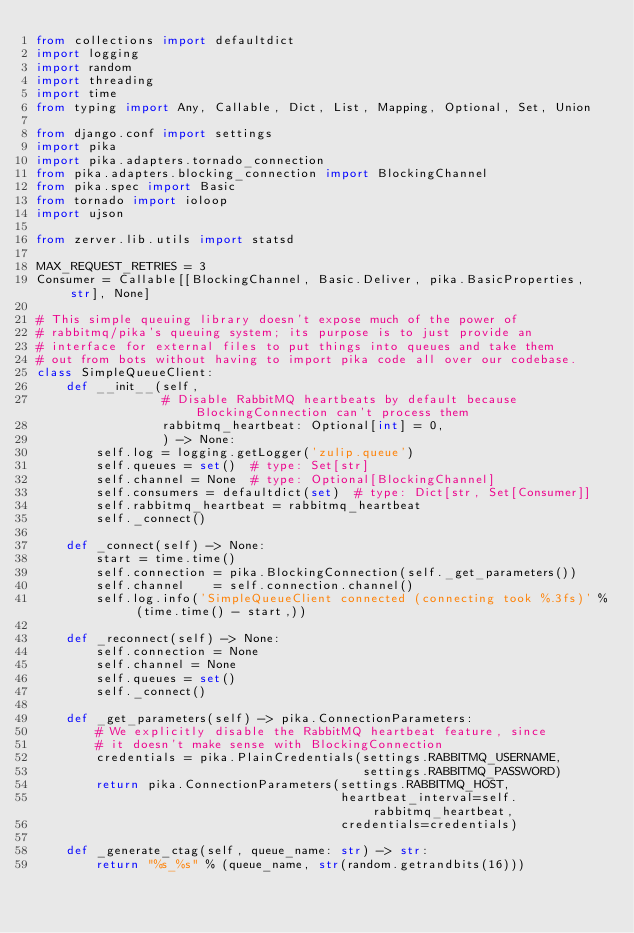Convert code to text. <code><loc_0><loc_0><loc_500><loc_500><_Python_>from collections import defaultdict
import logging
import random
import threading
import time
from typing import Any, Callable, Dict, List, Mapping, Optional, Set, Union

from django.conf import settings
import pika
import pika.adapters.tornado_connection
from pika.adapters.blocking_connection import BlockingChannel
from pika.spec import Basic
from tornado import ioloop
import ujson

from zerver.lib.utils import statsd

MAX_REQUEST_RETRIES = 3
Consumer = Callable[[BlockingChannel, Basic.Deliver, pika.BasicProperties, str], None]

# This simple queuing library doesn't expose much of the power of
# rabbitmq/pika's queuing system; its purpose is to just provide an
# interface for external files to put things into queues and take them
# out from bots without having to import pika code all over our codebase.
class SimpleQueueClient:
    def __init__(self,
                 # Disable RabbitMQ heartbeats by default because BlockingConnection can't process them
                 rabbitmq_heartbeat: Optional[int] = 0,
                 ) -> None:
        self.log = logging.getLogger('zulip.queue')
        self.queues = set()  # type: Set[str]
        self.channel = None  # type: Optional[BlockingChannel]
        self.consumers = defaultdict(set)  # type: Dict[str, Set[Consumer]]
        self.rabbitmq_heartbeat = rabbitmq_heartbeat
        self._connect()

    def _connect(self) -> None:
        start = time.time()
        self.connection = pika.BlockingConnection(self._get_parameters())
        self.channel    = self.connection.channel()
        self.log.info('SimpleQueueClient connected (connecting took %.3fs)' % (time.time() - start,))

    def _reconnect(self) -> None:
        self.connection = None
        self.channel = None
        self.queues = set()
        self._connect()

    def _get_parameters(self) -> pika.ConnectionParameters:
        # We explicitly disable the RabbitMQ heartbeat feature, since
        # it doesn't make sense with BlockingConnection
        credentials = pika.PlainCredentials(settings.RABBITMQ_USERNAME,
                                            settings.RABBITMQ_PASSWORD)
        return pika.ConnectionParameters(settings.RABBITMQ_HOST,
                                         heartbeat_interval=self.rabbitmq_heartbeat,
                                         credentials=credentials)

    def _generate_ctag(self, queue_name: str) -> str:
        return "%s_%s" % (queue_name, str(random.getrandbits(16)))
</code> 